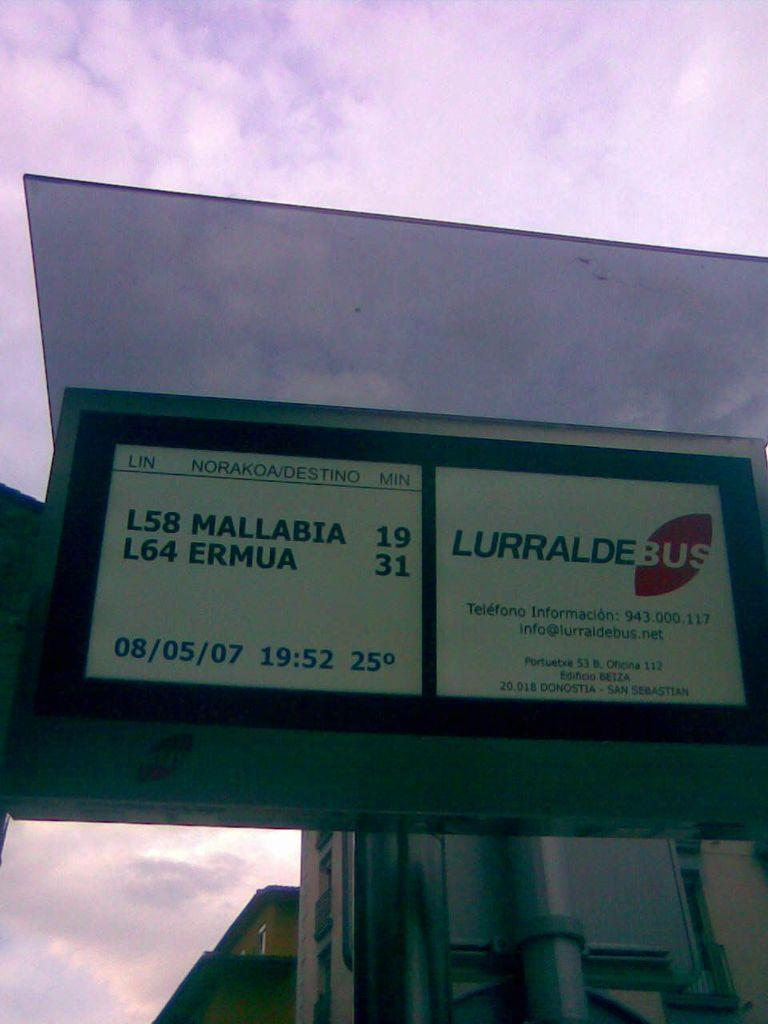<image>
Create a compact narrative representing the image presented. A bus sign for Lurralde bus on the date of 08/05/07. 